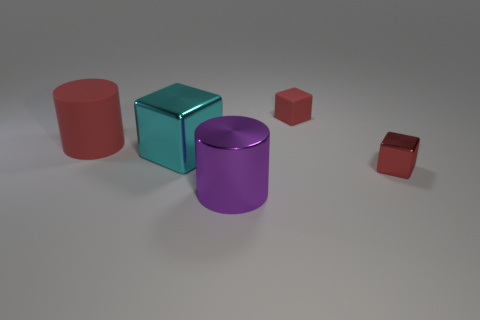How many large things are purple cylinders or metal things?
Give a very brief answer. 2. Do the metal cube to the right of the purple cylinder and the tiny block behind the red cylinder have the same color?
Offer a very short reply. Yes. What number of other things are there of the same color as the matte cube?
Your response must be concise. 2. There is a small red object behind the small red metal object; what shape is it?
Your response must be concise. Cube. Are there fewer big purple metallic objects than tiny blue rubber cylinders?
Your answer should be compact. No. Is the cylinder right of the large metal cube made of the same material as the large red cylinder?
Keep it short and to the point. No. Are there any other things that are the same size as the red metal thing?
Your response must be concise. Yes. There is a red rubber cube; are there any tiny things to the left of it?
Your answer should be compact. No. What color is the block that is to the left of the large cylinder on the right side of the cylinder that is left of the purple metallic thing?
Make the answer very short. Cyan. There is a rubber object that is the same size as the cyan block; what is its shape?
Make the answer very short. Cylinder. 